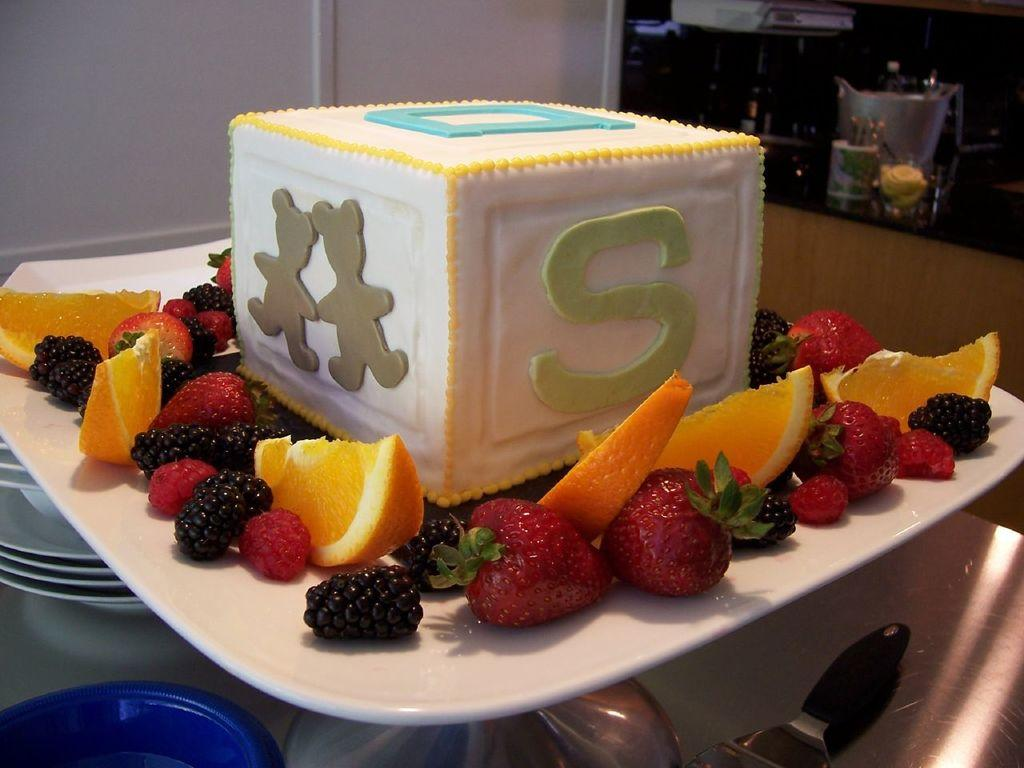What is the main subject on the plate in the image? There is a food item on a white color plate in the image. What other items are present around the food item? There are fruits around the food item. What can be seen in the background of the image? There is a wall in the background of the image. What type of trade is happening in the image? There is no trade happening in the image; it features a food item on a plate with fruits around it and a wall in the background. Can you see any branches in the image? There are no branches visible in the image. 